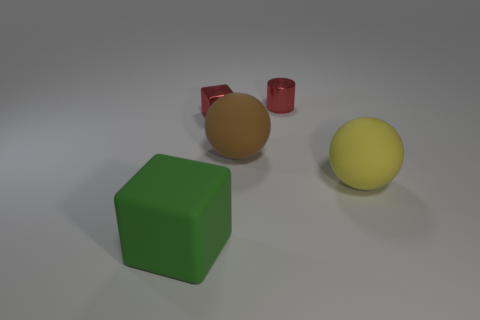Add 3 small rubber things. How many objects exist? 8 Subtract all balls. How many objects are left? 3 Subtract 0 brown cylinders. How many objects are left? 5 Subtract all small brown shiny things. Subtract all red cylinders. How many objects are left? 4 Add 4 small red metal cubes. How many small red metal cubes are left? 5 Add 2 small green metallic blocks. How many small green metallic blocks exist? 2 